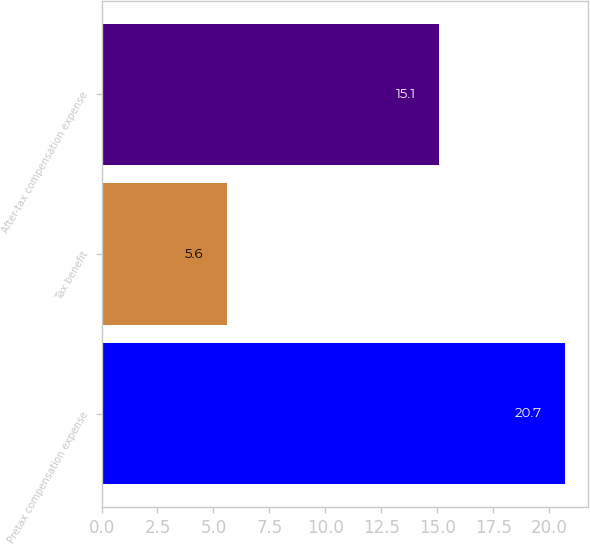<chart> <loc_0><loc_0><loc_500><loc_500><bar_chart><fcel>Pretax compensation expense<fcel>Tax benefit<fcel>After-tax compensation expense<nl><fcel>20.7<fcel>5.6<fcel>15.1<nl></chart> 